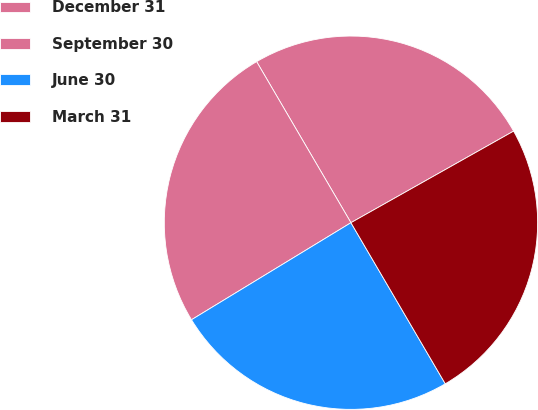Convert chart. <chart><loc_0><loc_0><loc_500><loc_500><pie_chart><fcel>December 31<fcel>September 30<fcel>June 30<fcel>March 31<nl><fcel>25.27%<fcel>25.27%<fcel>24.73%<fcel>24.73%<nl></chart> 